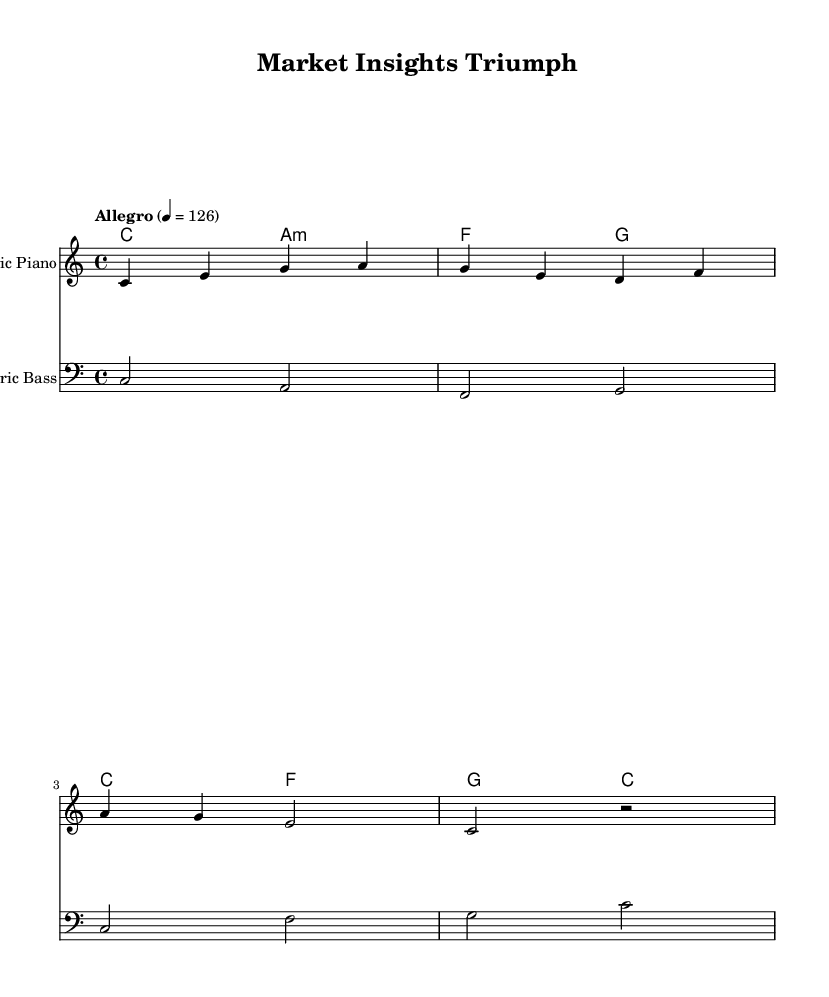What is the key signature of this music? The key signature is indicated by the `\key` command in the code. It specifies C major, which has no sharps or flats.
Answer: C major What is the time signature of this music? The time signature is shown by the `\time` command in the code. It is 4/4, which means there are four beats in each measure.
Answer: 4/4 What is the tempo marking for this piece? The tempo is indicated by the `\tempo` command. It is specified as Allegro, with a metronome marking of 126 beats per minute.
Answer: Allegro 126 How many measures are in the melody section? By counting the distinct lines in the melody, there are a total of four measures represented with each line ending at the bar line.
Answer: 4 What is the third chord in the harmony? The chords are listed in the `harmony` section. The third chord is `c2`, which correlates to the C major chord.
Answer: C major What instrument plays the melody? The instrument is specified in the `\new Staff \with` section of the code, indicating the music is played on the Electric Piano.
Answer: Electric Piano What is the last note of the bass part? The last note of the bass part is determined by examining the notation of the bass line, where the last note shown is `c`.
Answer: c 